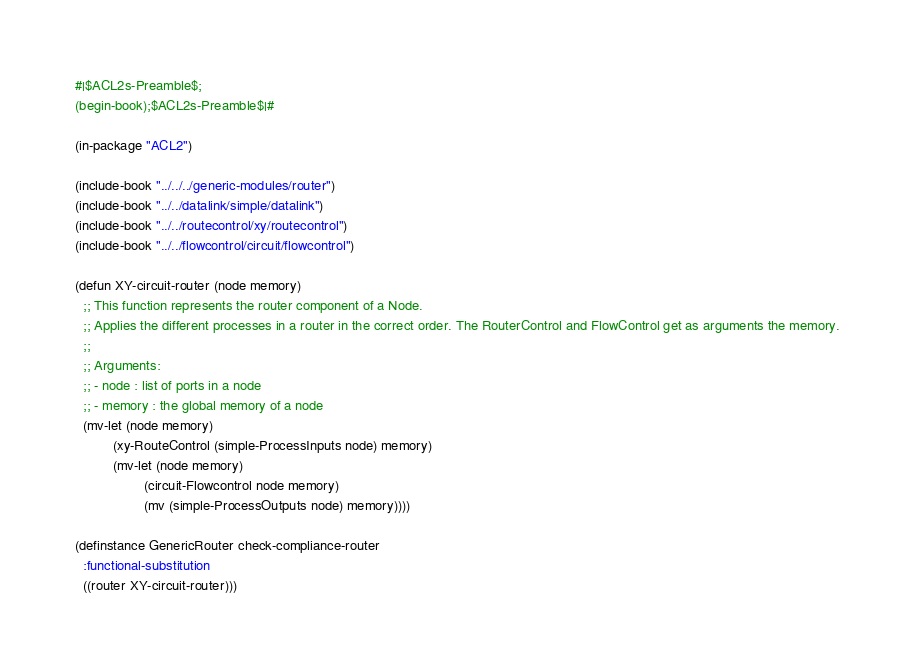Convert code to text. <code><loc_0><loc_0><loc_500><loc_500><_Lisp_>#|$ACL2s-Preamble$;
(begin-book);$ACL2s-Preamble$|#

(in-package "ACL2")

(include-book "../../../generic-modules/router")
(include-book "../../datalink/simple/datalink")
(include-book "../../routecontrol/xy/routecontrol")
(include-book "../../flowcontrol/circuit/flowcontrol")

(defun XY-circuit-router (node memory)  
  ;; This function represents the router component of a Node.
  ;; Applies the different processes in a router in the correct order. The RouterControl and FlowControl get as arguments the memory. 
  ;;
  ;; Arguments:
  ;; - node : list of ports in a node
  ;; - memory : the global memory of a node
  (mv-let (node memory)
          (xy-RouteControl (simple-ProcessInputs node) memory)
          (mv-let (node memory)
                  (circuit-Flowcontrol node memory)
                  (mv (simple-ProcessOutputs node) memory))))

(definstance GenericRouter check-compliance-router                   
  :functional-substitution
  ((router XY-circuit-router)))


</code> 